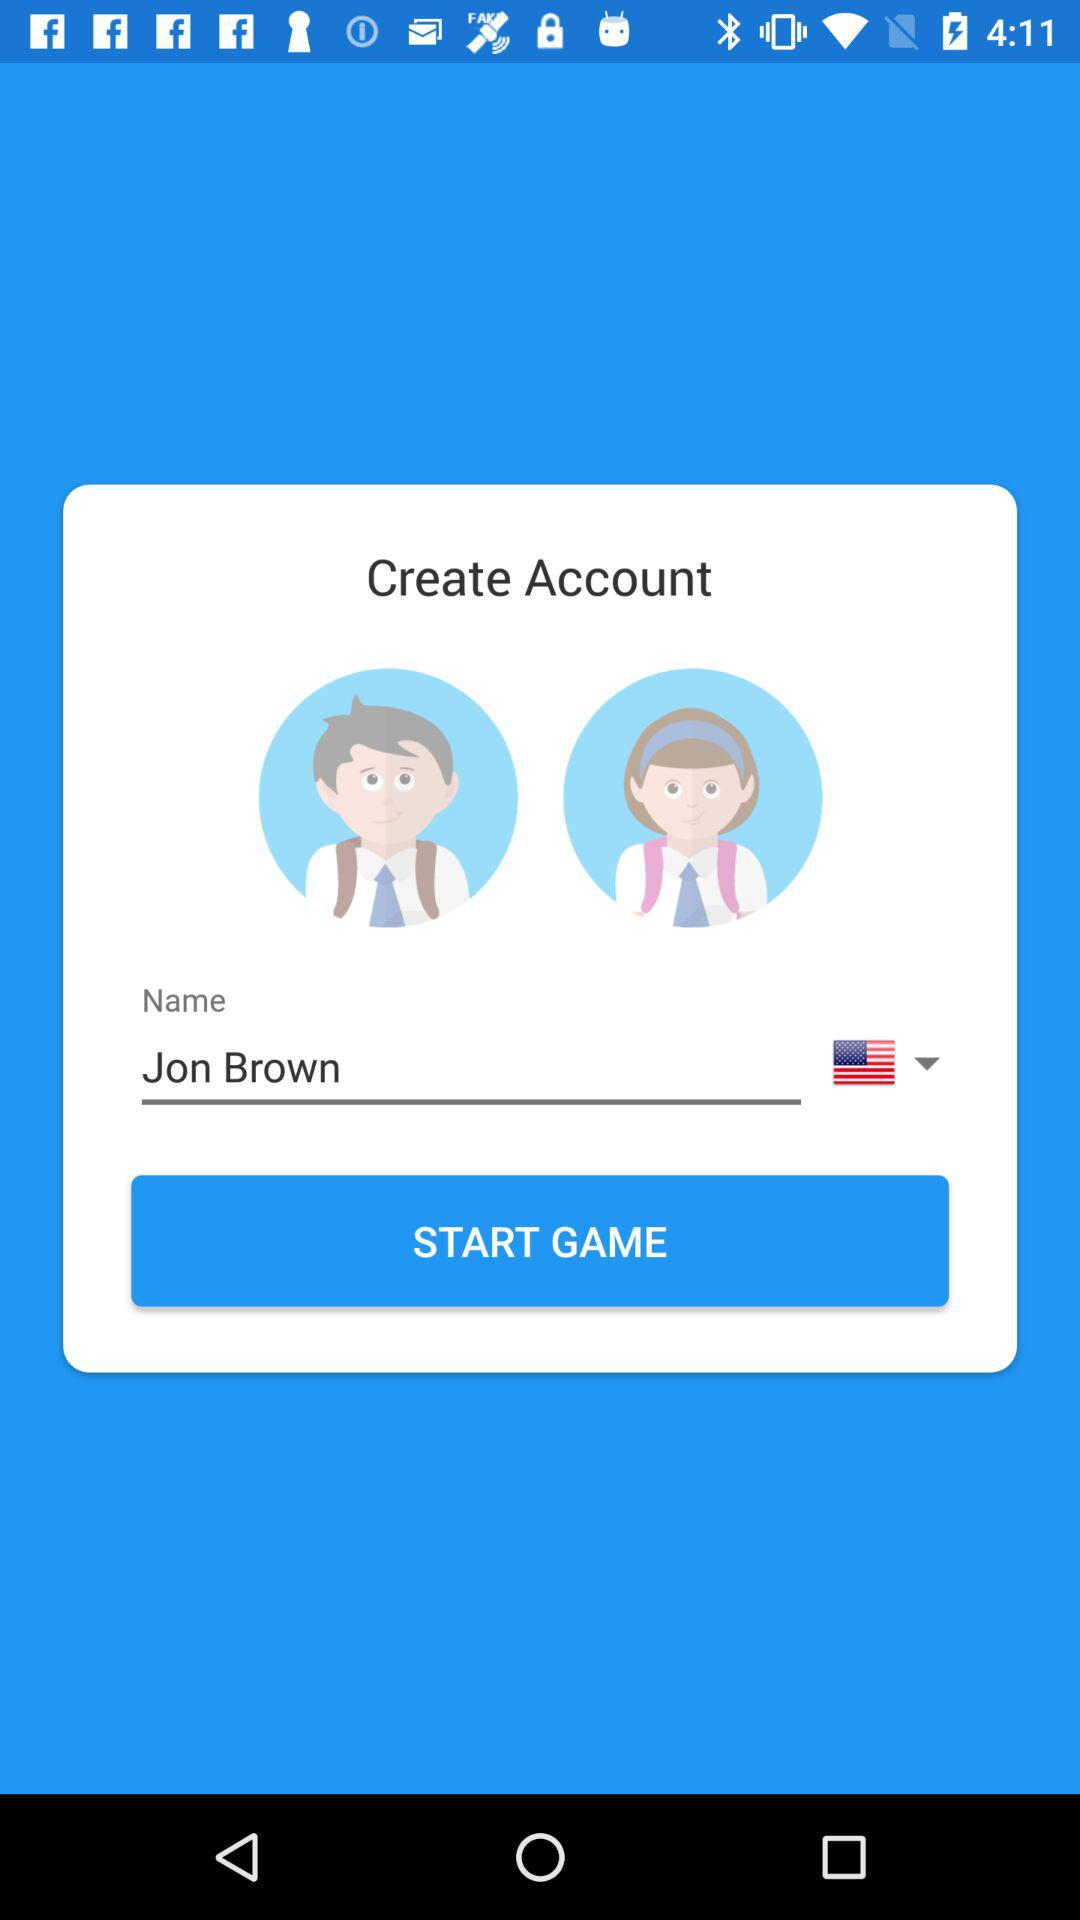What are the countries listed in the drop-down menu?
When the provided information is insufficient, respond with <no answer>. <no answer> 